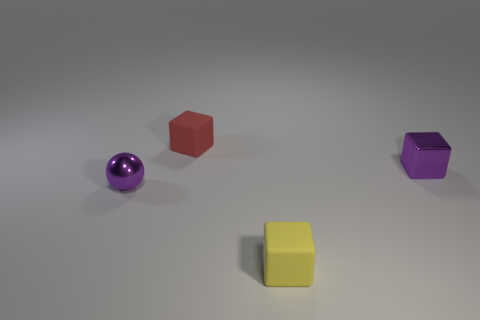The other tiny matte thing that is the same shape as the yellow thing is what color? red 